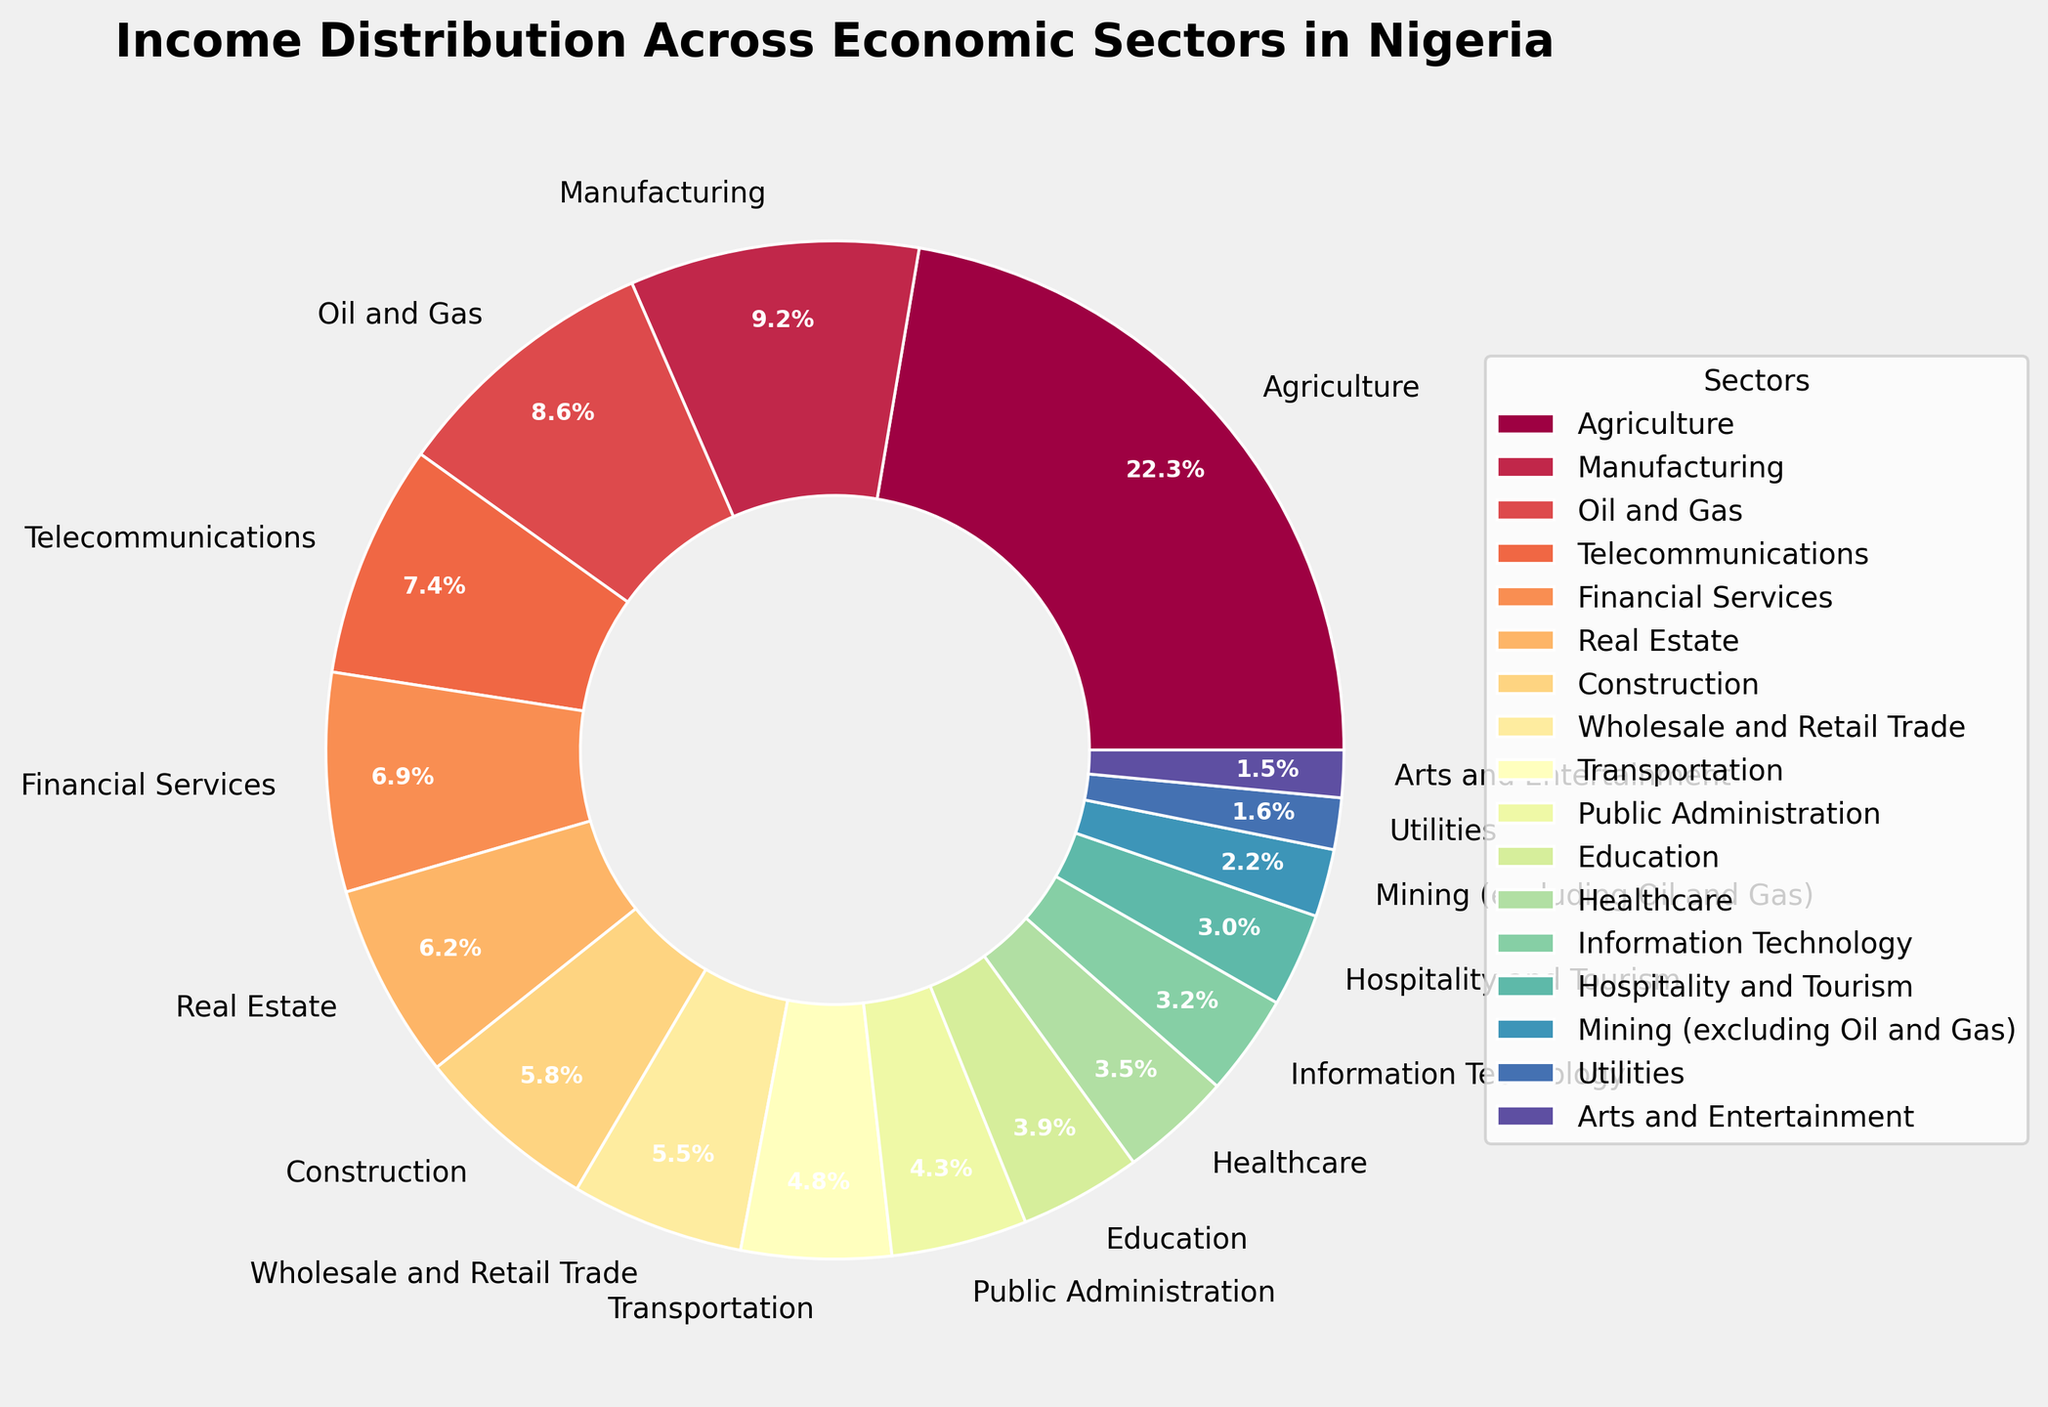What percentage of income is contributed by the Agriculture sector? Look at the segment labeled "Agriculture" in the pie chart and observe the percentage value displayed.
Answer: 22.35% Which sector contributes more to the income distribution, Financial Services or Real Estate? Compare the percentage values of Financial Services (6.95%) and Real Estate (6.21%) shown on the pie chart.
Answer: Financial Services What is the combined income contribution percentage of the Telecommunications and Healthcare sectors? Add the percentages of Telecommunications (7.42%) and Healthcare (3.54%). Calculation: 7.42% + 3.54% = 10.96%
Answer: 10.96% Which sector has the smallest income contribution percentage? Identify the sector with the smallest value by comparing all the sectors' percentages in the pie chart.
Answer: Arts and Entertainment How does the percentage contribution of the Oil and Gas sector compare to that of the Manufacturing sector? Compare the percentages of Oil and Gas (8.60%) and Manufacturing (9.18%) shown on the pie chart to determine which is higher or if they are equal.
Answer: Manufacturing sector is higher What is the difference in income contribution percentages between the Public Administration and Education sectors? Subtract the percentage of the Education sector (3.87%) from that of Public Administration (4.32%). Calculation: 4.32% - 3.87% = 0.45%
Answer: 0.45% If we combine the income contributions of the three smallest sectors, what is their total percentage? Add the percentages of the three smallest sectors: Arts and Entertainment (1.50%), Utilities (1.64%), and Mining (excluding Oil and Gas) (2.15%). Calculation: 1.50% + 1.64% + 2.15% = 5.29%
Answer: 5.29% What is the visual color representation for the sector with the highest income contribution? Identify the segment with the highest percentage (Agriculture) and note the color used to represent it on the pie chart.
Answer: (This answer is based on the actual visual inspection of the chart, possible response could be if seen): Light Green Which sector falls in between Transportation and Public Administration in terms of income contribution percentage? Identify the sectors listed in the pie chart and determine which one has a percentage between Transportation (4.76%) and Public Administration (4.32%).
Answer: Transportation 